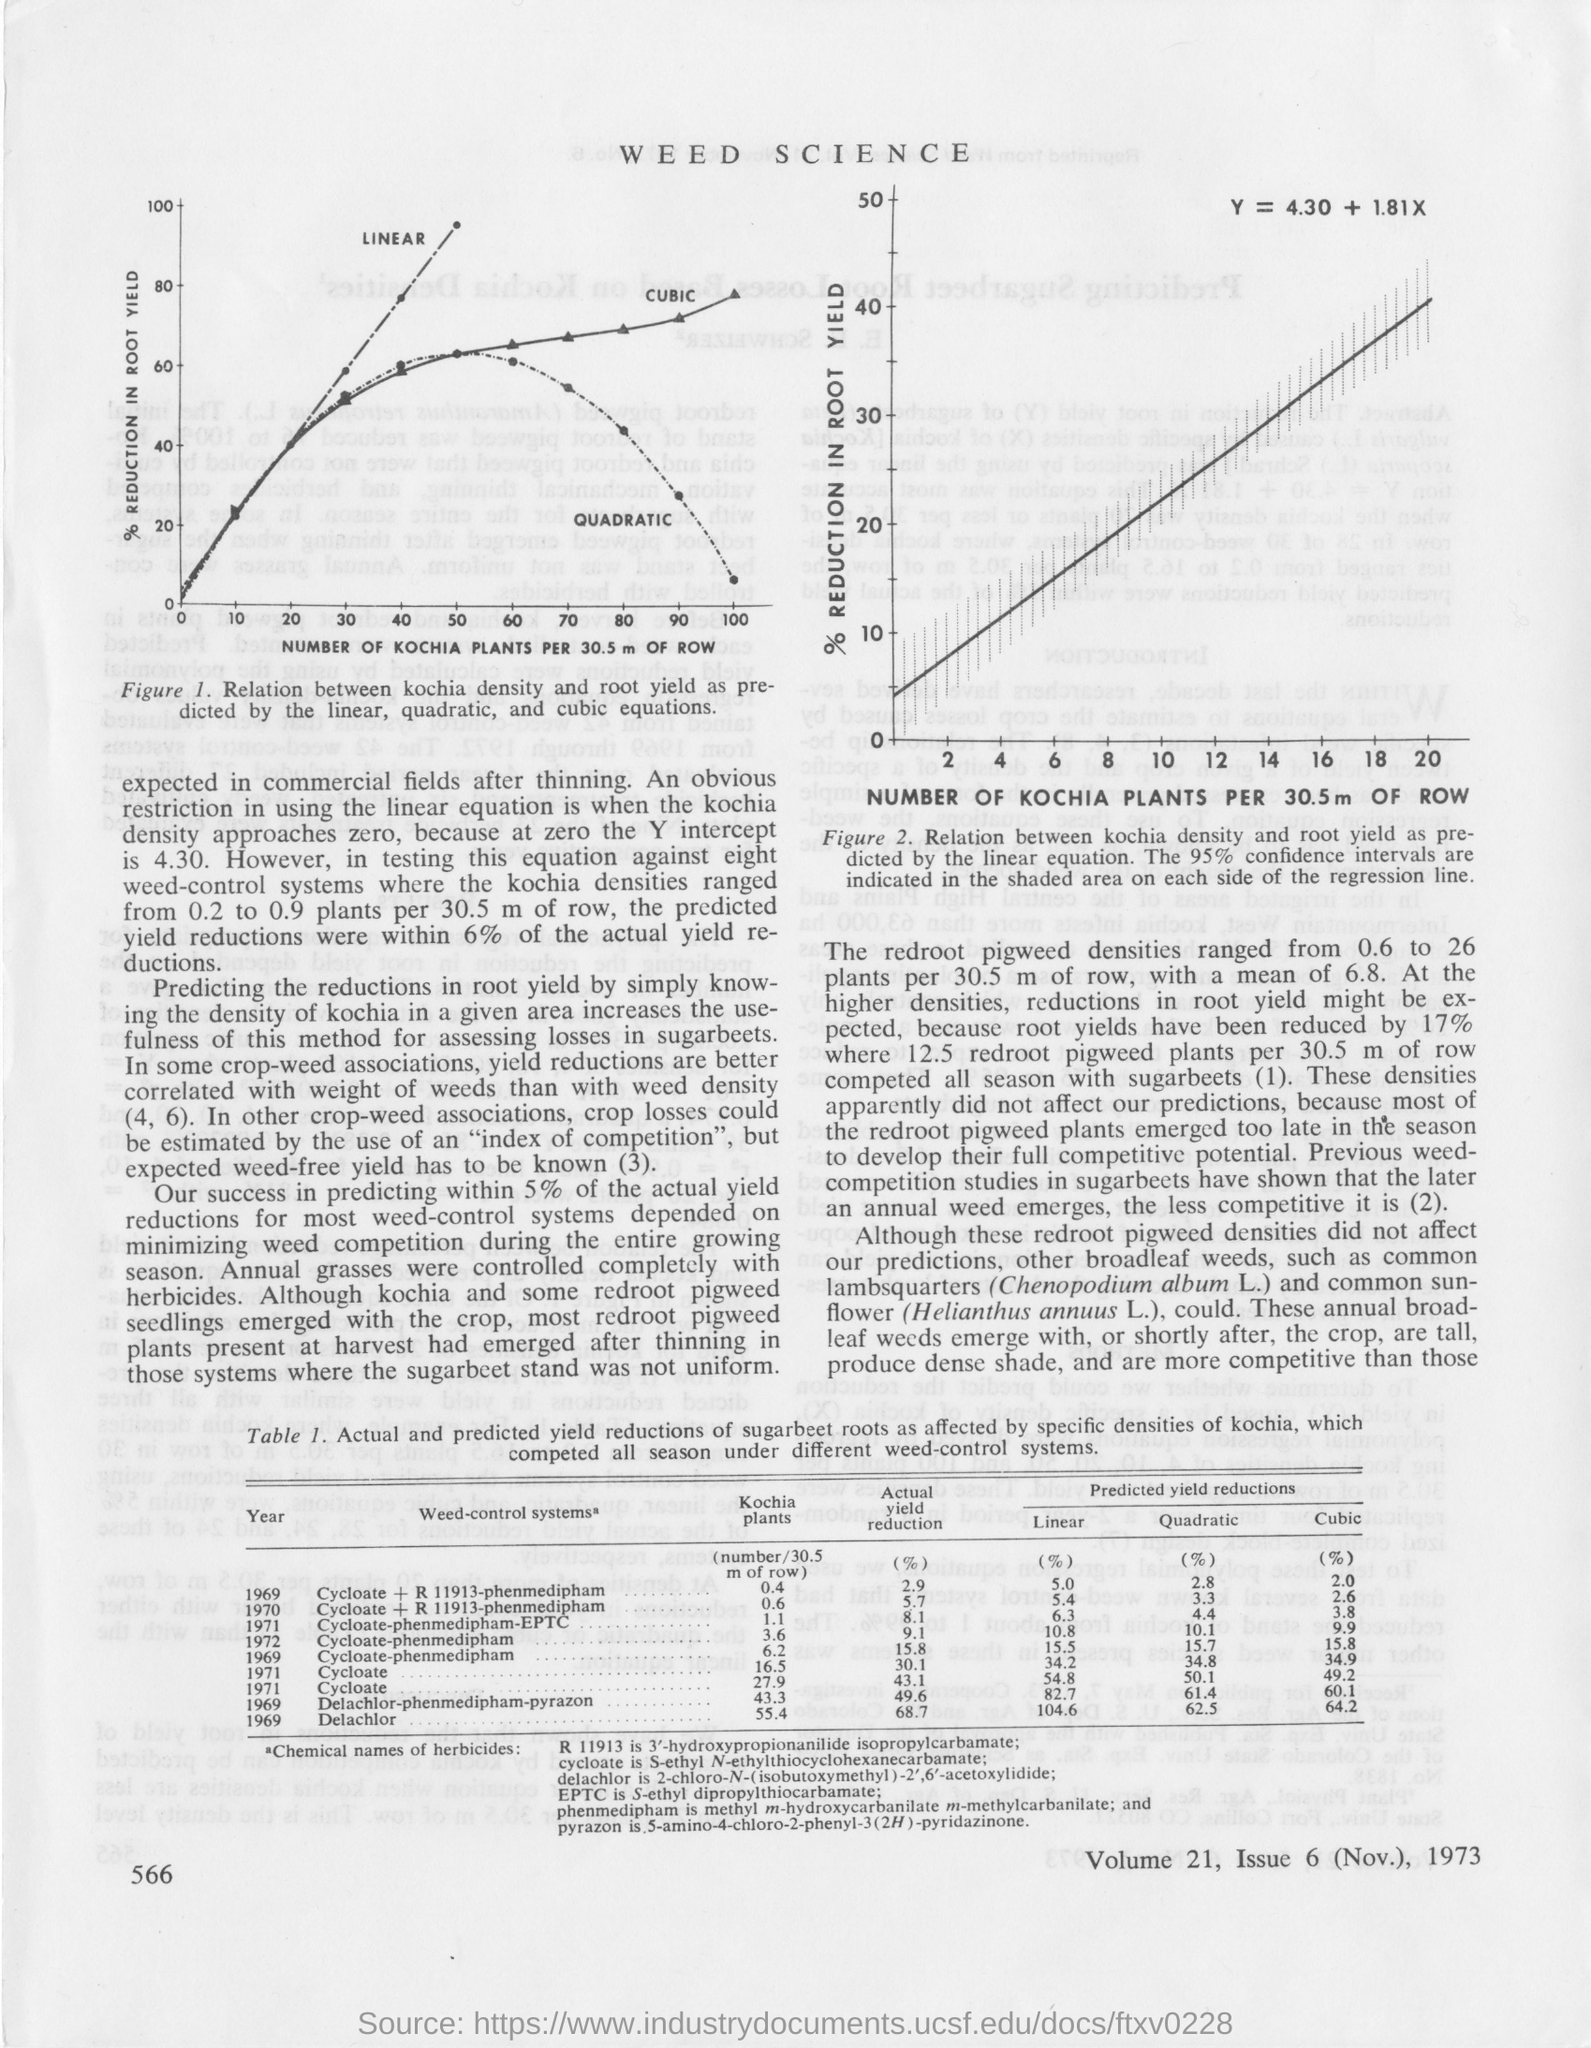What is the first title in the document?
Offer a very short reply. WEED SCIENCE. What is the formula to calculate Y?
Ensure brevity in your answer.  Y = 4.30 + 1.81X. 